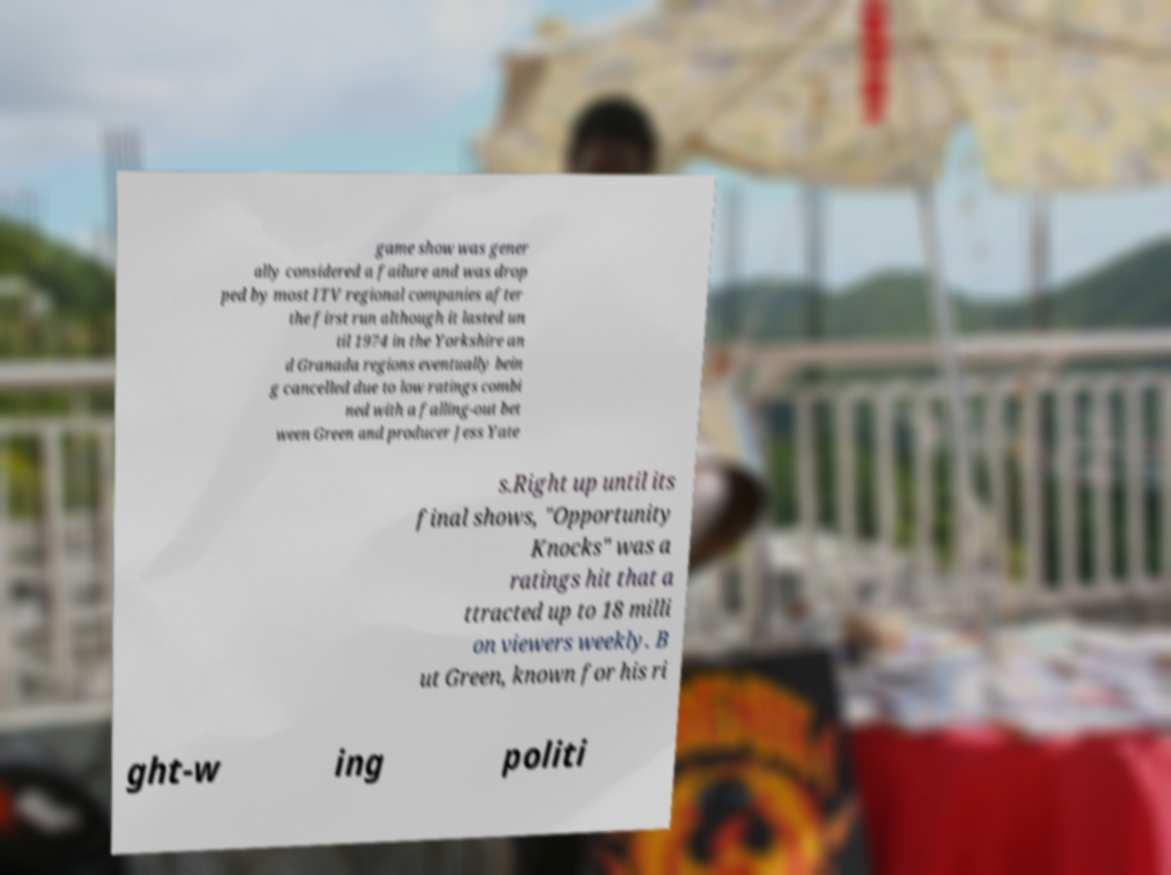For documentation purposes, I need the text within this image transcribed. Could you provide that? game show was gener ally considered a failure and was drop ped by most ITV regional companies after the first run although it lasted un til 1974 in the Yorkshire an d Granada regions eventually bein g cancelled due to low ratings combi ned with a falling-out bet ween Green and producer Jess Yate s.Right up until its final shows, "Opportunity Knocks" was a ratings hit that a ttracted up to 18 milli on viewers weekly. B ut Green, known for his ri ght-w ing politi 